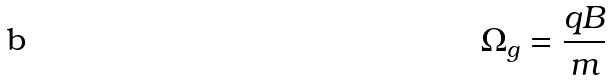Convert formula to latex. <formula><loc_0><loc_0><loc_500><loc_500>\Omega _ { g } = \frac { q B } { m }</formula> 